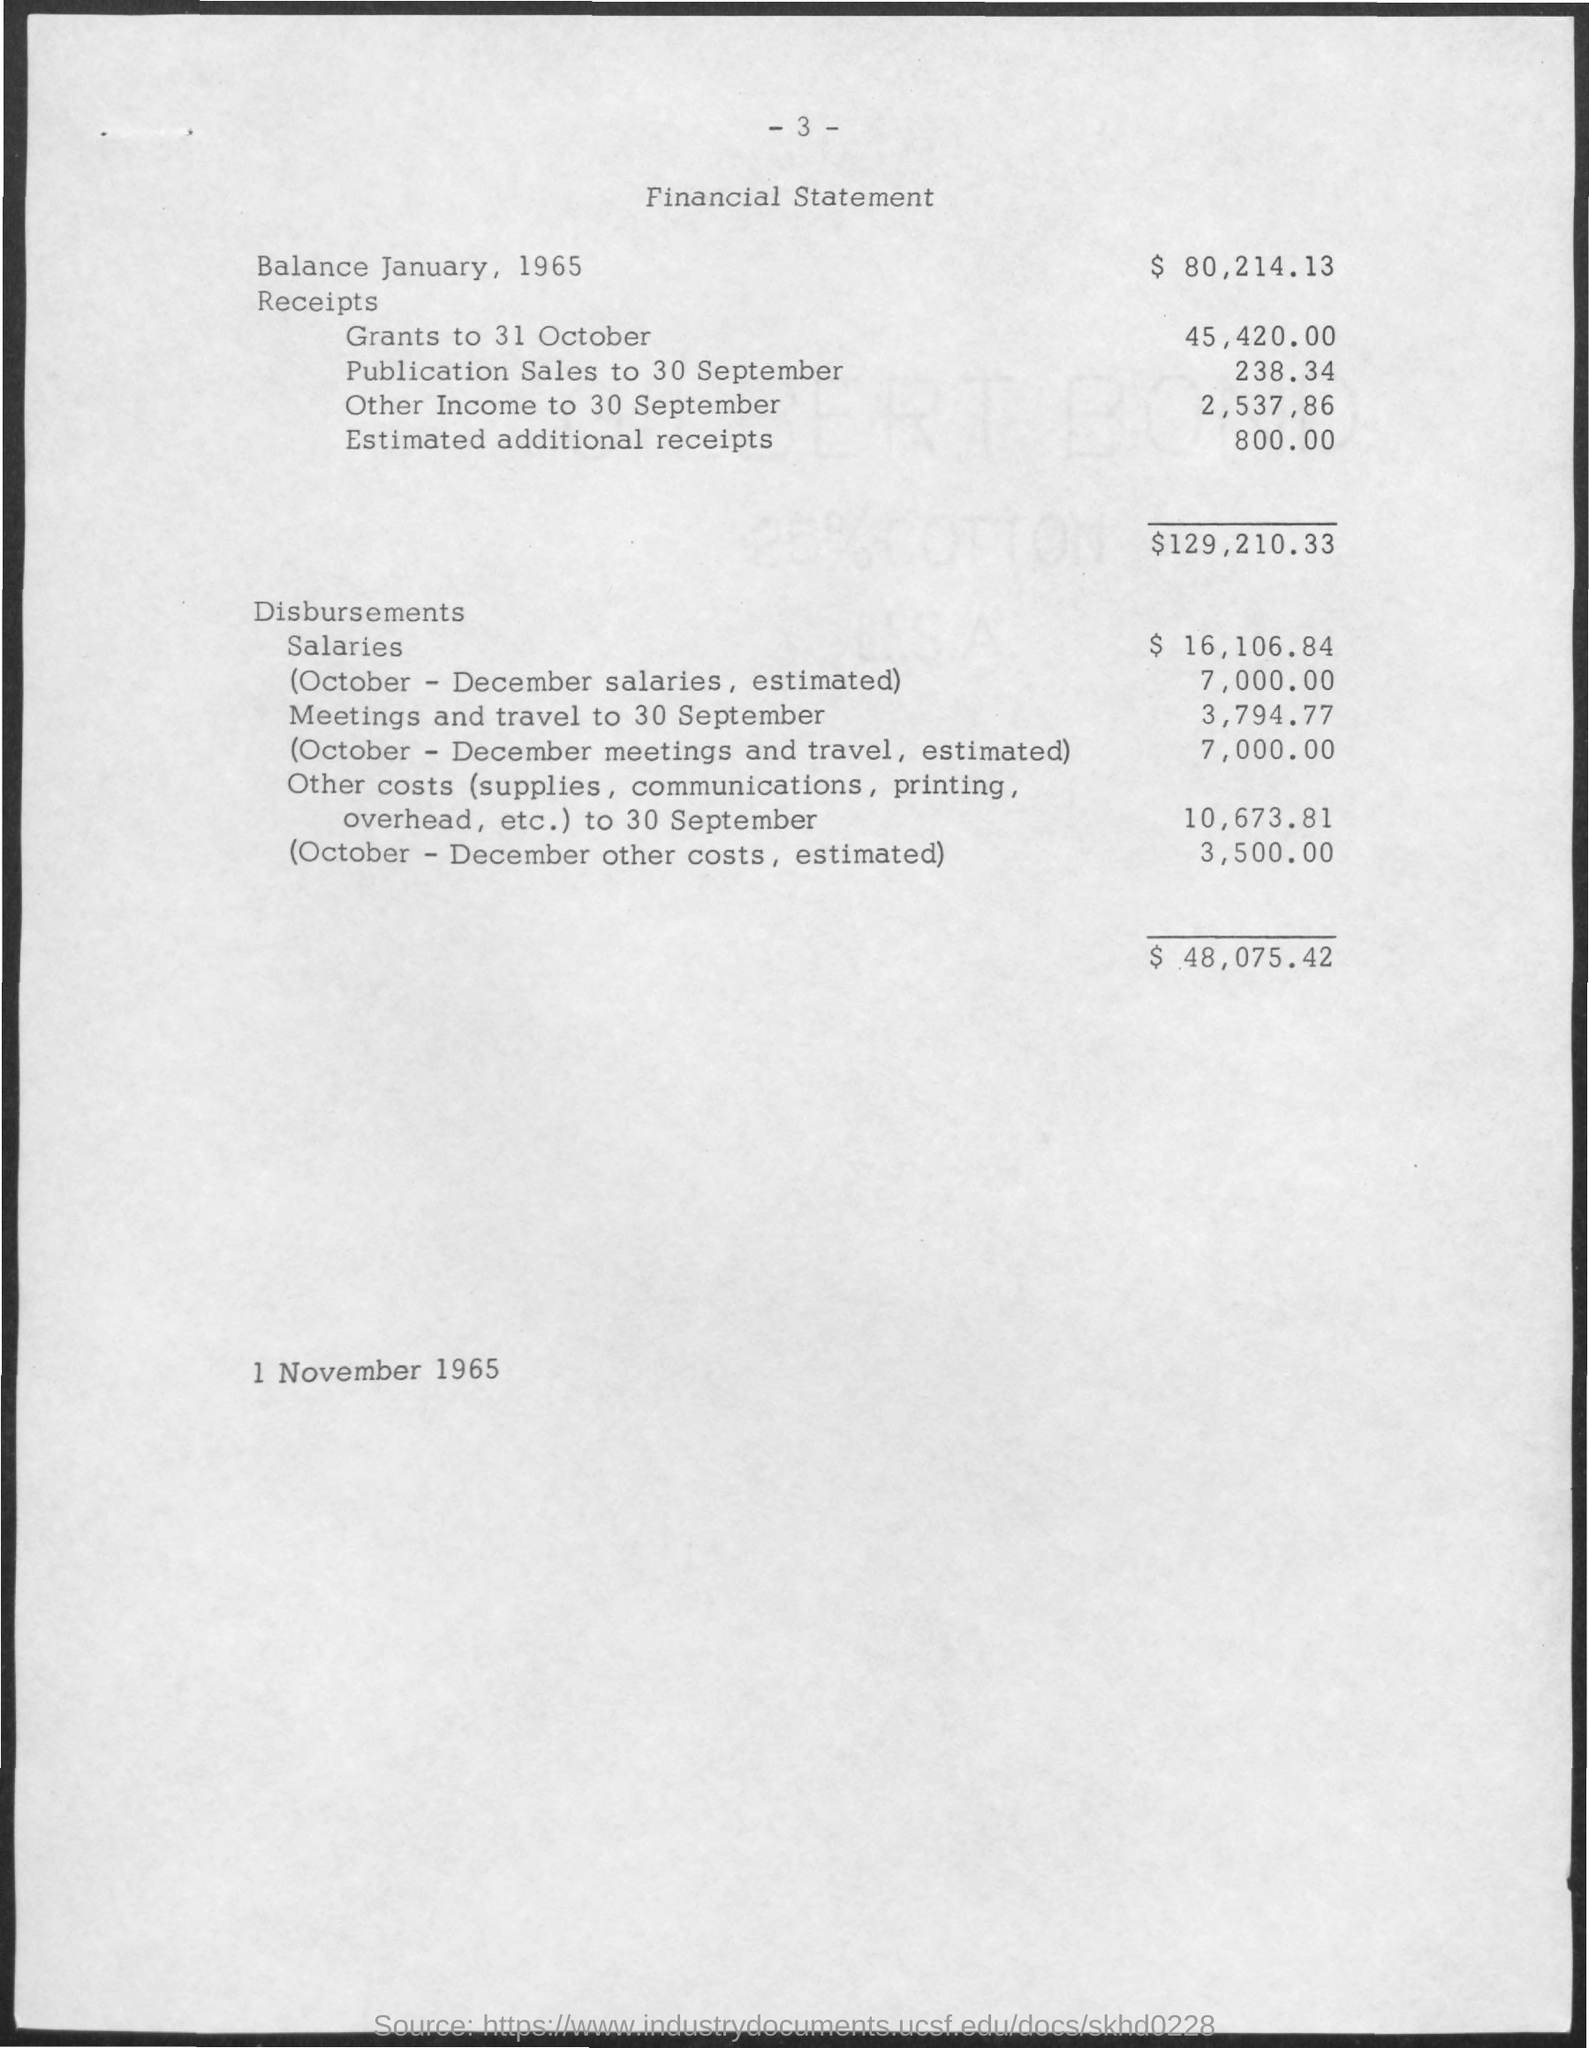Indicate a few pertinent items in this graphic. At the top of the page, the current page number is 3. The amount of salary in Disbursements is 16,106.84. On the bottom of the page, it is written, "1 November 1965... The estimated additional receipts in Receipts are approximately $800.00. The amount of publication sales for the month of September is $238.34. 